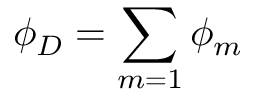<formula> <loc_0><loc_0><loc_500><loc_500>\phi _ { D } = \sum _ { m = 1 } \phi _ { m }</formula> 